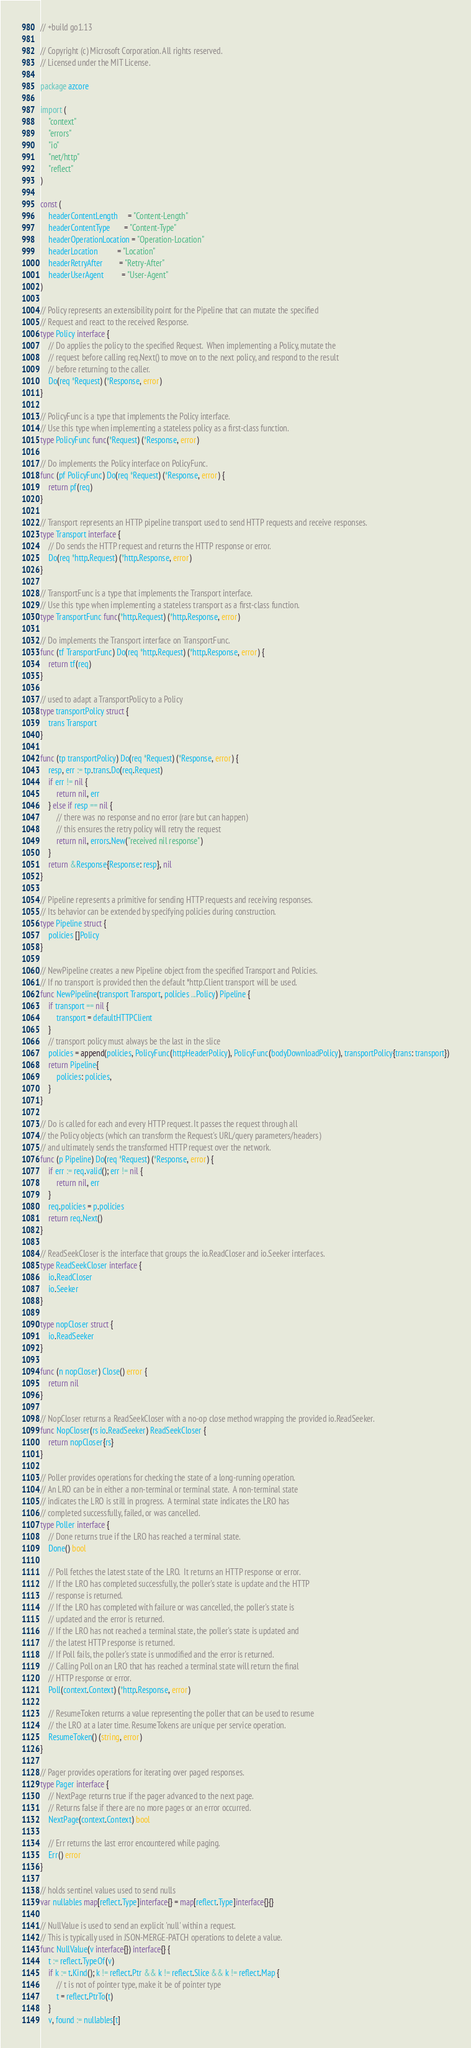Convert code to text. <code><loc_0><loc_0><loc_500><loc_500><_Go_>// +build go1.13

// Copyright (c) Microsoft Corporation. All rights reserved.
// Licensed under the MIT License.

package azcore

import (
	"context"
	"errors"
	"io"
	"net/http"
	"reflect"
)

const (
	headerContentLength     = "Content-Length"
	headerContentType       = "Content-Type"
	headerOperationLocation = "Operation-Location"
	headerLocation          = "Location"
	headerRetryAfter        = "Retry-After"
	headerUserAgent         = "User-Agent"
)

// Policy represents an extensibility point for the Pipeline that can mutate the specified
// Request and react to the received Response.
type Policy interface {
	// Do applies the policy to the specified Request.  When implementing a Policy, mutate the
	// request before calling req.Next() to move on to the next policy, and respond to the result
	// before returning to the caller.
	Do(req *Request) (*Response, error)
}

// PolicyFunc is a type that implements the Policy interface.
// Use this type when implementing a stateless policy as a first-class function.
type PolicyFunc func(*Request) (*Response, error)

// Do implements the Policy interface on PolicyFunc.
func (pf PolicyFunc) Do(req *Request) (*Response, error) {
	return pf(req)
}

// Transport represents an HTTP pipeline transport used to send HTTP requests and receive responses.
type Transport interface {
	// Do sends the HTTP request and returns the HTTP response or error.
	Do(req *http.Request) (*http.Response, error)
}

// TransportFunc is a type that implements the Transport interface.
// Use this type when implementing a stateless transport as a first-class function.
type TransportFunc func(*http.Request) (*http.Response, error)

// Do implements the Transport interface on TransportFunc.
func (tf TransportFunc) Do(req *http.Request) (*http.Response, error) {
	return tf(req)
}

// used to adapt a TransportPolicy to a Policy
type transportPolicy struct {
	trans Transport
}

func (tp transportPolicy) Do(req *Request) (*Response, error) {
	resp, err := tp.trans.Do(req.Request)
	if err != nil {
		return nil, err
	} else if resp == nil {
		// there was no response and no error (rare but can happen)
		// this ensures the retry policy will retry the request
		return nil, errors.New("received nil response")
	}
	return &Response{Response: resp}, nil
}

// Pipeline represents a primitive for sending HTTP requests and receiving responses.
// Its behavior can be extended by specifying policies during construction.
type Pipeline struct {
	policies []Policy
}

// NewPipeline creates a new Pipeline object from the specified Transport and Policies.
// If no transport is provided then the default *http.Client transport will be used.
func NewPipeline(transport Transport, policies ...Policy) Pipeline {
	if transport == nil {
		transport = defaultHTTPClient
	}
	// transport policy must always be the last in the slice
	policies = append(policies, PolicyFunc(httpHeaderPolicy), PolicyFunc(bodyDownloadPolicy), transportPolicy{trans: transport})
	return Pipeline{
		policies: policies,
	}
}

// Do is called for each and every HTTP request. It passes the request through all
// the Policy objects (which can transform the Request's URL/query parameters/headers)
// and ultimately sends the transformed HTTP request over the network.
func (p Pipeline) Do(req *Request) (*Response, error) {
	if err := req.valid(); err != nil {
		return nil, err
	}
	req.policies = p.policies
	return req.Next()
}

// ReadSeekCloser is the interface that groups the io.ReadCloser and io.Seeker interfaces.
type ReadSeekCloser interface {
	io.ReadCloser
	io.Seeker
}

type nopCloser struct {
	io.ReadSeeker
}

func (n nopCloser) Close() error {
	return nil
}

// NopCloser returns a ReadSeekCloser with a no-op close method wrapping the provided io.ReadSeeker.
func NopCloser(rs io.ReadSeeker) ReadSeekCloser {
	return nopCloser{rs}
}

// Poller provides operations for checking the state of a long-running operation.
// An LRO can be in either a non-terminal or terminal state.  A non-terminal state
// indicates the LRO is still in progress.  A terminal state indicates the LRO has
// completed successfully, failed, or was cancelled.
type Poller interface {
	// Done returns true if the LRO has reached a terminal state.
	Done() bool

	// Poll fetches the latest state of the LRO.  It returns an HTTP response or error.
	// If the LRO has completed successfully, the poller's state is update and the HTTP
	// response is returned.
	// If the LRO has completed with failure or was cancelled, the poller's state is
	// updated and the error is returned.
	// If the LRO has not reached a terminal state, the poller's state is updated and
	// the latest HTTP response is returned.
	// If Poll fails, the poller's state is unmodified and the error is returned.
	// Calling Poll on an LRO that has reached a terminal state will return the final
	// HTTP response or error.
	Poll(context.Context) (*http.Response, error)

	// ResumeToken returns a value representing the poller that can be used to resume
	// the LRO at a later time. ResumeTokens are unique per service operation.
	ResumeToken() (string, error)
}

// Pager provides operations for iterating over paged responses.
type Pager interface {
	// NextPage returns true if the pager advanced to the next page.
	// Returns false if there are no more pages or an error occurred.
	NextPage(context.Context) bool

	// Err returns the last error encountered while paging.
	Err() error
}

// holds sentinel values used to send nulls
var nullables map[reflect.Type]interface{} = map[reflect.Type]interface{}{}

// NullValue is used to send an explicit 'null' within a request.
// This is typically used in JSON-MERGE-PATCH operations to delete a value.
func NullValue(v interface{}) interface{} {
	t := reflect.TypeOf(v)
	if k := t.Kind(); k != reflect.Ptr && k != reflect.Slice && k != reflect.Map {
		// t is not of pointer type, make it be of pointer type
		t = reflect.PtrTo(t)
	}
	v, found := nullables[t]</code> 